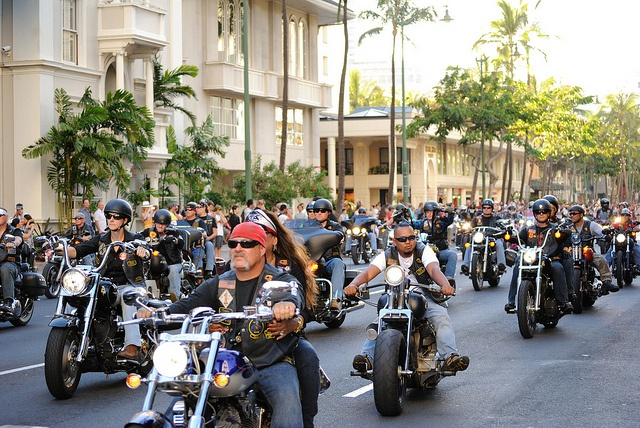Describe the objects in this image and their specific colors. I can see motorcycle in gray, black, and white tones, people in gray, black, and white tones, motorcycle in gray, black, white, and darkgray tones, motorcycle in gray, black, darkgray, and white tones, and people in gray, black, darkgray, and white tones in this image. 